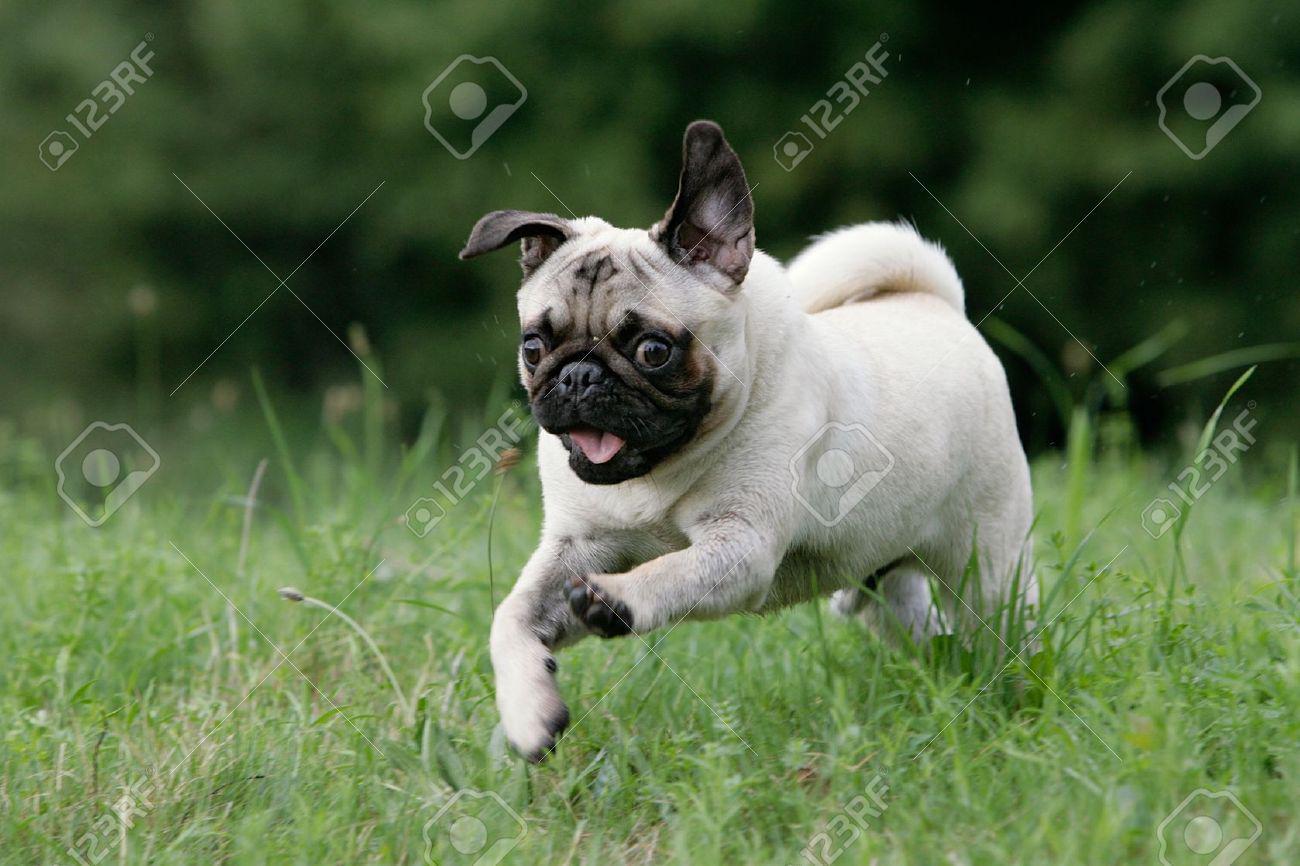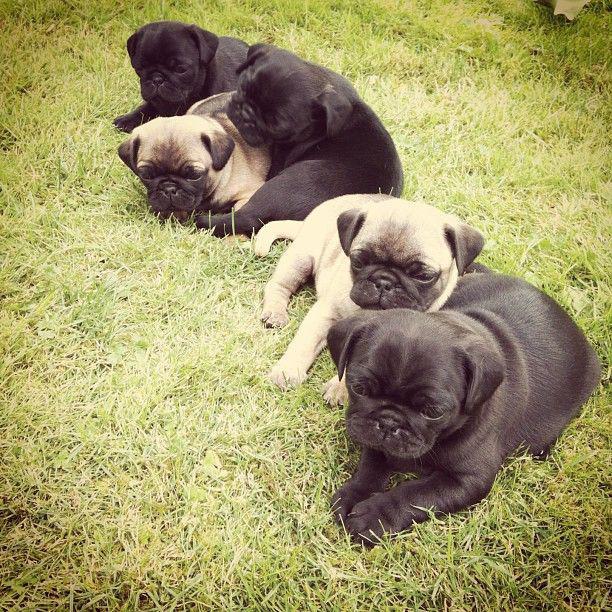The first image is the image on the left, the second image is the image on the right. Assess this claim about the two images: "A dog is running.". Correct or not? Answer yes or no. Yes. The first image is the image on the left, the second image is the image on the right. Evaluate the accuracy of this statement regarding the images: "The right image contains at least three dogs.". Is it true? Answer yes or no. Yes. 